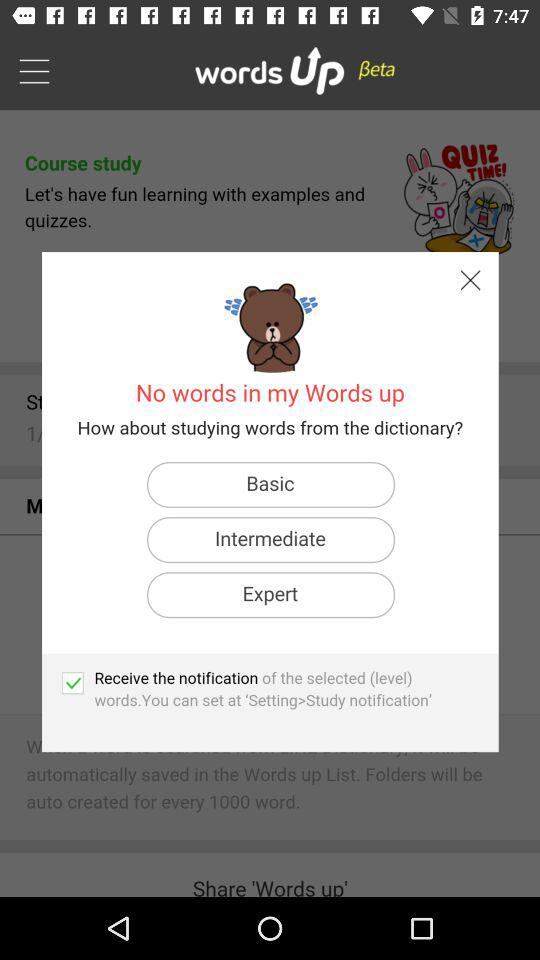How many levels are there?
Answer the question using a single word or phrase. 3 